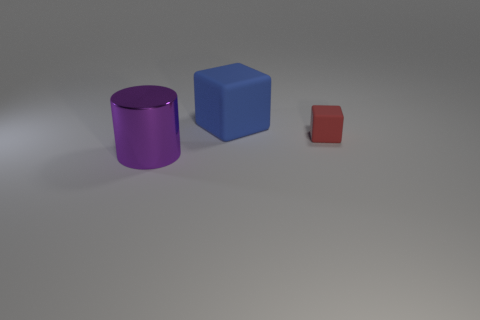Is there any other thing that is the same size as the red block?
Ensure brevity in your answer.  No. Is the color of the large block the same as the big metallic cylinder?
Your response must be concise. No. There is a rubber block on the right side of the big block; how big is it?
Offer a very short reply. Small. Are there any red rubber things of the same size as the blue object?
Your answer should be compact. No. There is a cube that is behind the red rubber object; is it the same size as the red matte cube?
Make the answer very short. No. What size is the red thing?
Offer a very short reply. Small. What is the color of the matte object that is in front of the rubber object that is to the left of the rubber block on the right side of the blue object?
Provide a succinct answer. Red. Does the big thing that is behind the purple thing have the same color as the metal object?
Keep it short and to the point. No. How many objects are in front of the blue matte object and to the left of the small block?
Your response must be concise. 1. There is another matte object that is the same shape as the large blue object; what is its size?
Provide a succinct answer. Small. 